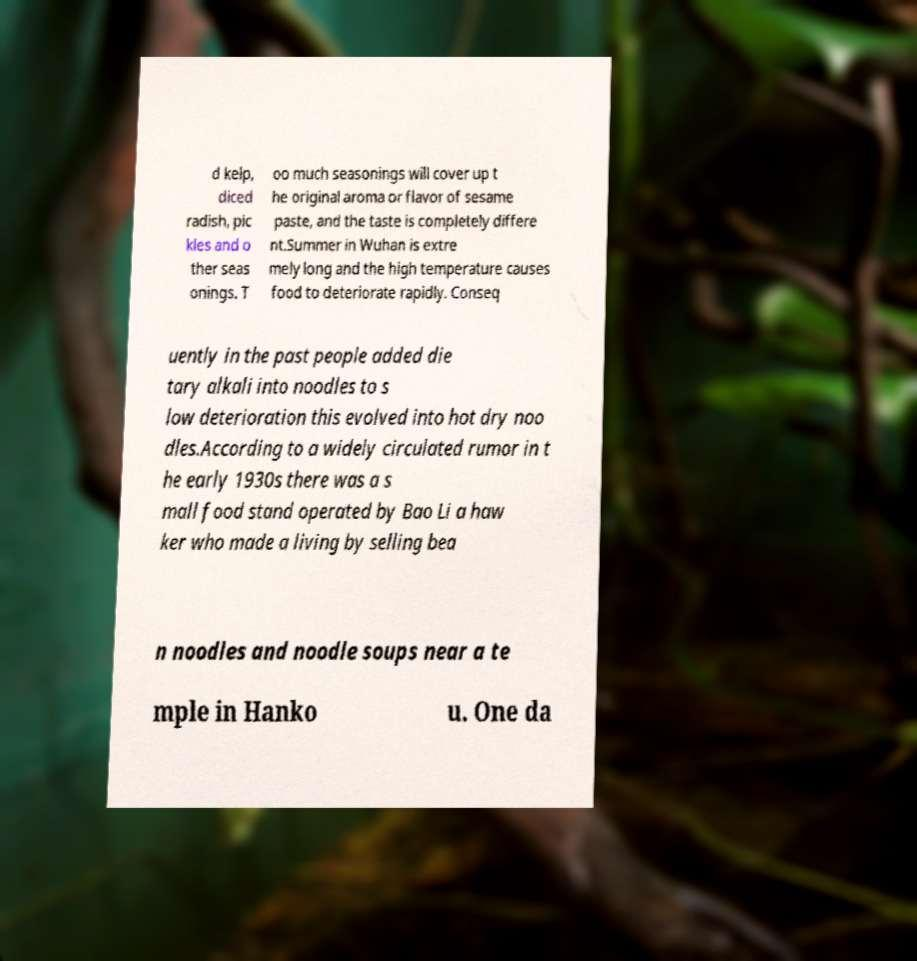Please identify and transcribe the text found in this image. d kelp, diced radish, pic kles and o ther seas onings. T oo much seasonings will cover up t he original aroma or flavor of sesame paste, and the taste is completely differe nt.Summer in Wuhan is extre mely long and the high temperature causes food to deteriorate rapidly. Conseq uently in the past people added die tary alkali into noodles to s low deterioration this evolved into hot dry noo dles.According to a widely circulated rumor in t he early 1930s there was a s mall food stand operated by Bao Li a haw ker who made a living by selling bea n noodles and noodle soups near a te mple in Hanko u. One da 